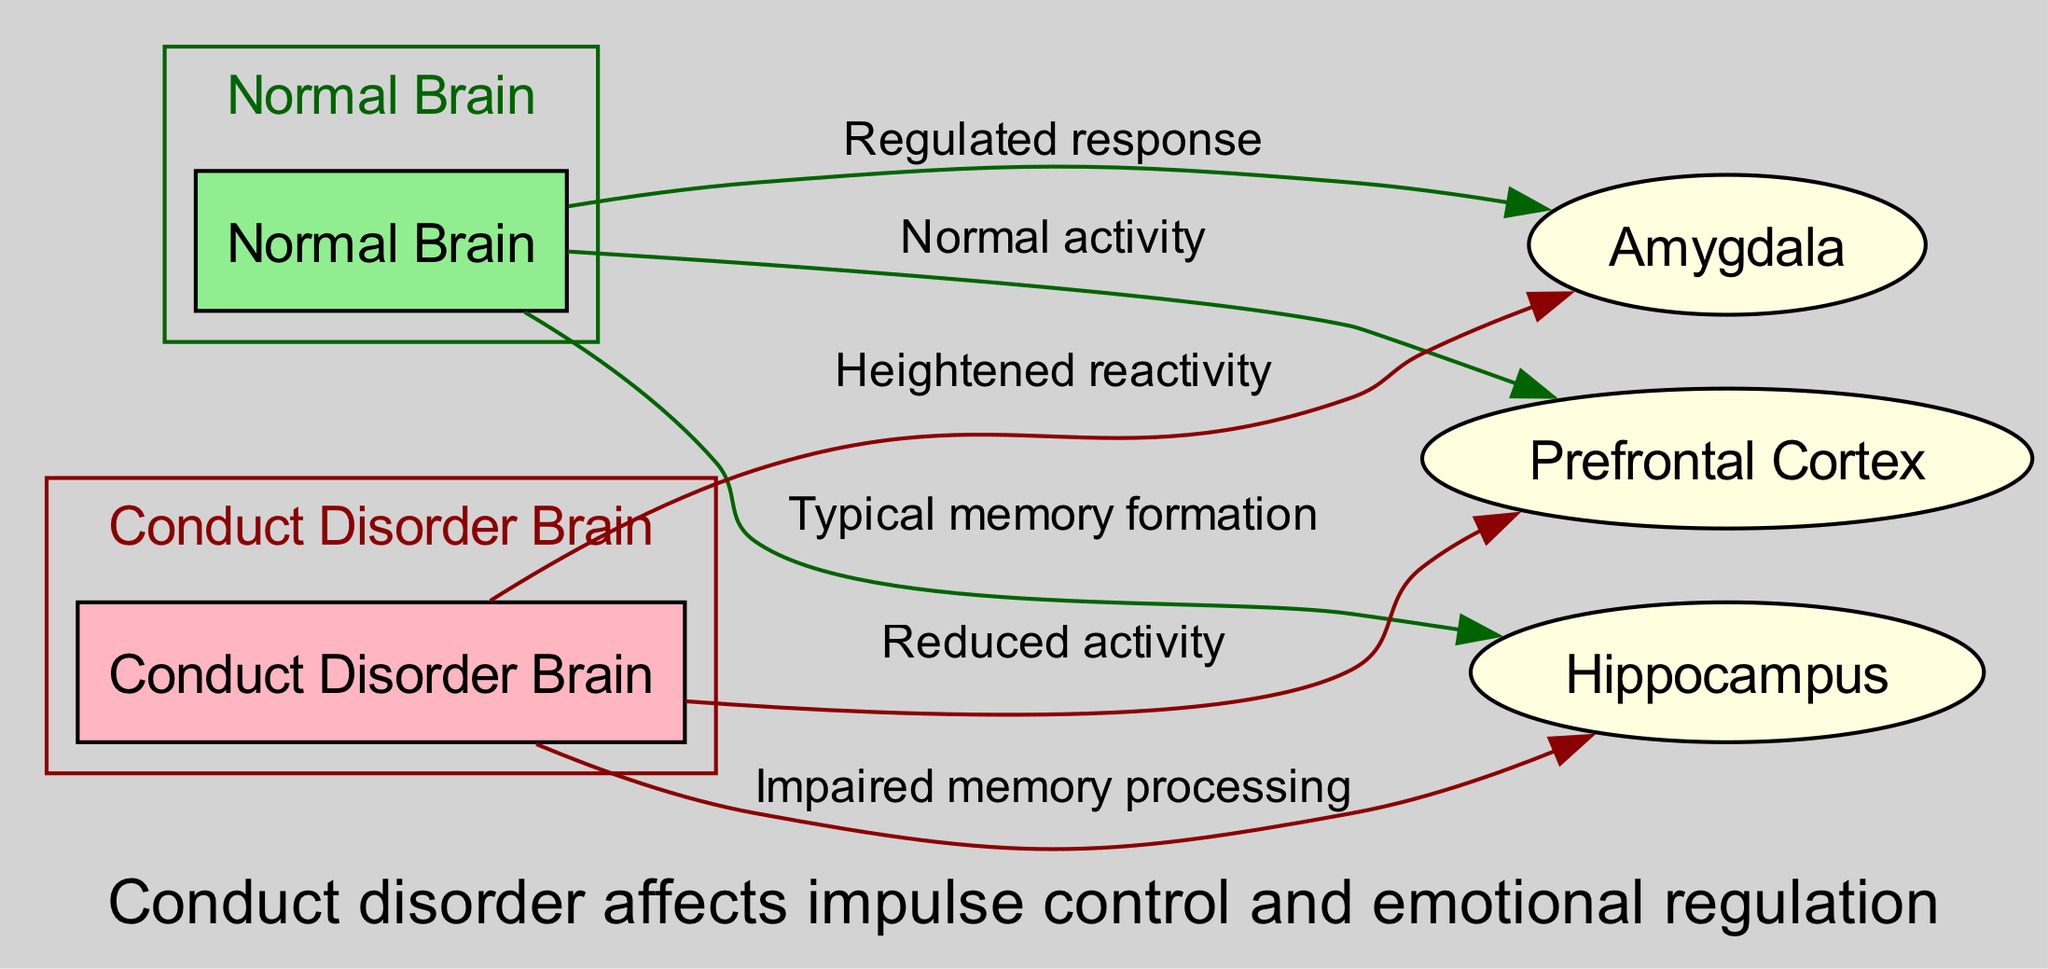What is the title of the diagram? The title is explicitly provided at the beginning of the diagram data. It indicates the comparison being made about brain activity.
Answer: Brain Activity: Normal vs. Conduct Disorder How many brain regions are highlighted in the diagram? By examining the node list, we can count that there are three distinct brain regions: Prefrontal Cortex, Amygdala, and Hippocampus.
Answer: 3 What type of brain activity is shown for the Normal Brain in the Prefrontal Cortex? The edge connecting the Normal Brain and the Prefrontal Cortex specifies the label "Normal activity," indicating the type of activity present in that region.
Answer: Normal activity What type of response is indicated for the Conduct Disorder Brain in the Amygdala? The edge connecting the Conduct Disorder Brain to the Amygdala shows the label "Heightened reactivity," which describes how the brain responds in this particular case.
Answer: Heightened reactivity What is the relationship between the Normal Brain and the Hippocampus? The edges connecting these two nodes indicate "Typical memory formation," which describes the type of activity occurring in that region for a Normal Brain.
Answer: Typical memory formation What is implied about impulse control in the context of Conduct Disorder? The annotation at the bottom of the diagram suggests a direct link between conduct disorder and issues related to impulse control, describing its effects generally.
Answer: Affects impulse control What is the primary difference in memory processing between normal brains and those with conduct disorder? The edge from the Conduct Disorder Brain to the Hippocampus indicates "Impaired memory processing," while normal brains experience typical memory formation, highlighting the contrast in their processing capabilities.
Answer: Impaired memory processing Which brain region is associated with emotion in both normal and conduct disorder brains? The Amygdala appears in both comparisons and includes different descriptors based on whether the activity is normal or affected by conduct disorder, indicating its involvement in emotional processing.
Answer: Amygdala What does the diagram suggest about emotional regulation in conduct disorder? The information provided in the annotation discusses the impact of conduct disorder on emotional regulation, implying that individuals with this condition struggle in that area.
Answer: Emotional regulation issues 